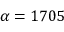<formula> <loc_0><loc_0><loc_500><loc_500>\alpha = 1 7 0 5</formula> 